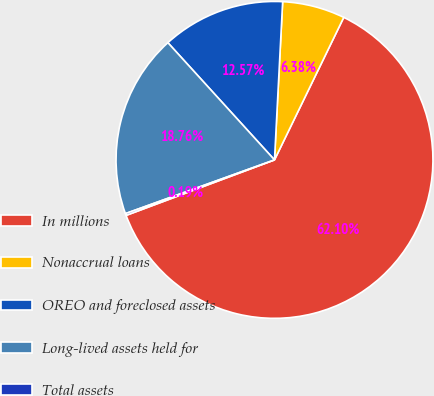Convert chart to OTSL. <chart><loc_0><loc_0><loc_500><loc_500><pie_chart><fcel>In millions<fcel>Nonaccrual loans<fcel>OREO and foreclosed assets<fcel>Long-lived assets held for<fcel>Total assets<nl><fcel>62.11%<fcel>6.38%<fcel>12.57%<fcel>18.76%<fcel>0.19%<nl></chart> 